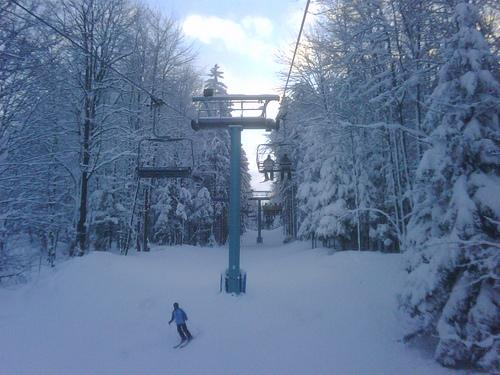Where are the people on the wire going?

Choices:
A) home
B) gift shop
C) bus stop
D) summit summit 